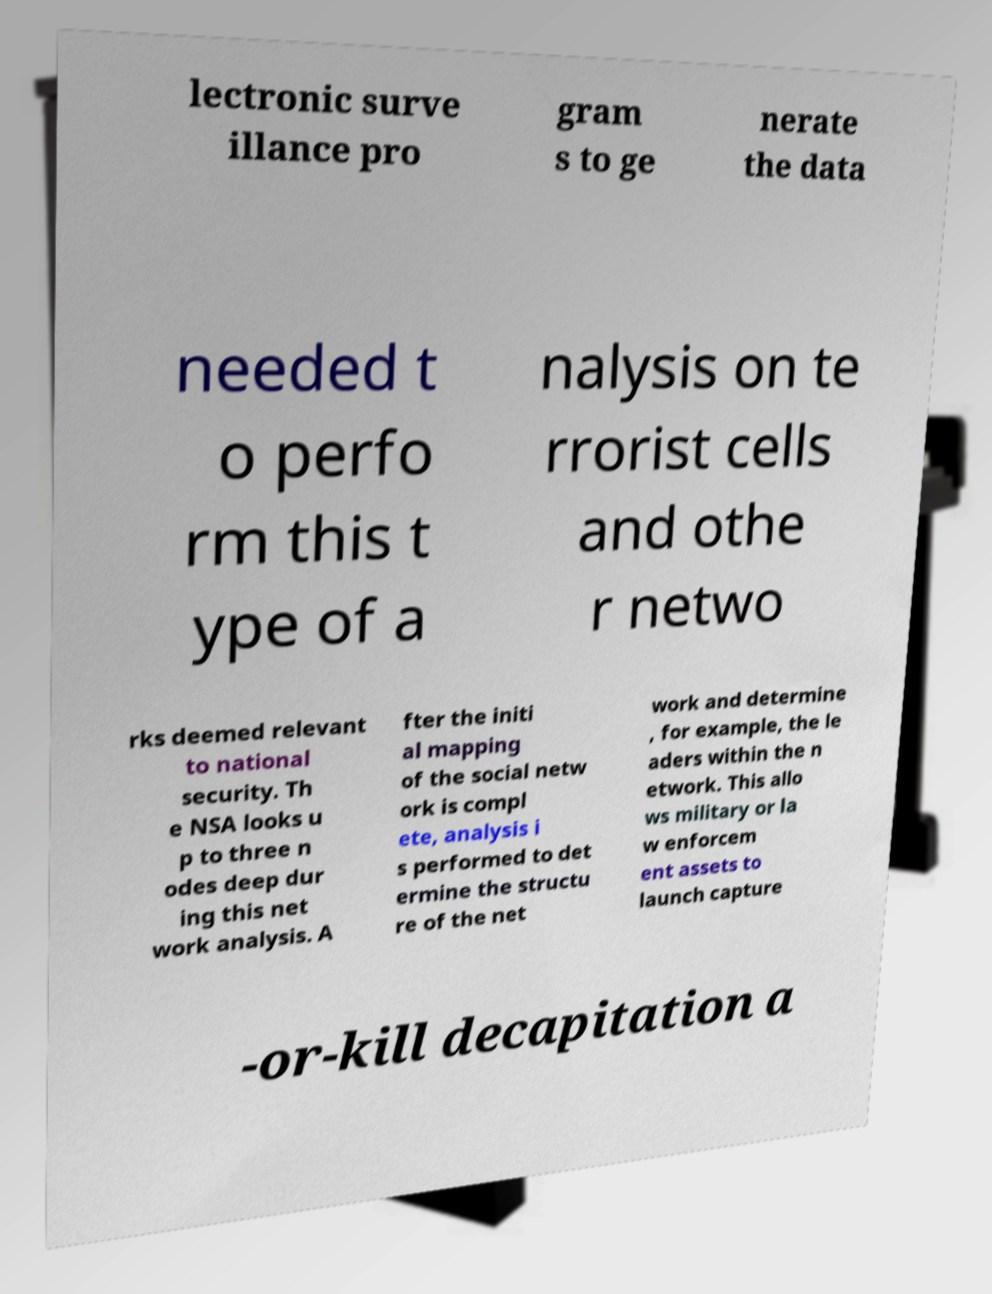I need the written content from this picture converted into text. Can you do that? lectronic surve illance pro gram s to ge nerate the data needed t o perfo rm this t ype of a nalysis on te rrorist cells and othe r netwo rks deemed relevant to national security. Th e NSA looks u p to three n odes deep dur ing this net work analysis. A fter the initi al mapping of the social netw ork is compl ete, analysis i s performed to det ermine the structu re of the net work and determine , for example, the le aders within the n etwork. This allo ws military or la w enforcem ent assets to launch capture -or-kill decapitation a 